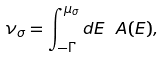Convert formula to latex. <formula><loc_0><loc_0><loc_500><loc_500>\nu _ { \sigma } = \int _ { - \Gamma } ^ { \mu _ { \sigma } } d E \ A ( E ) ,</formula> 